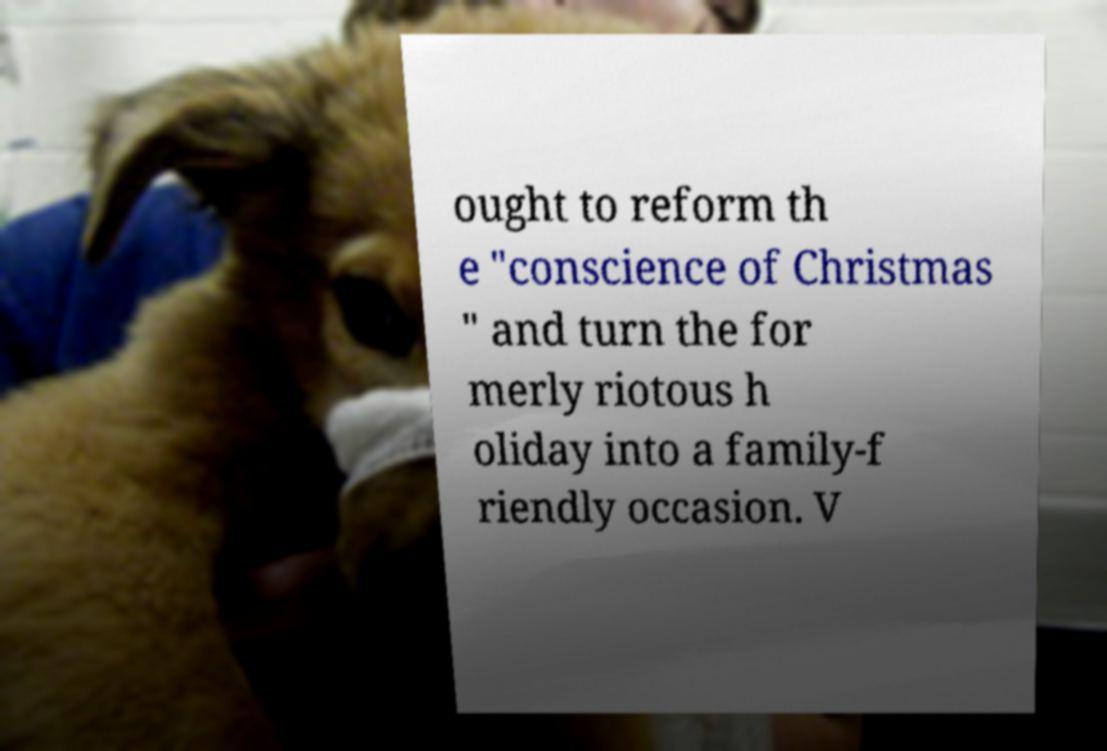Can you read and provide the text displayed in the image?This photo seems to have some interesting text. Can you extract and type it out for me? ought to reform th e "conscience of Christmas " and turn the for merly riotous h oliday into a family-f riendly occasion. V 